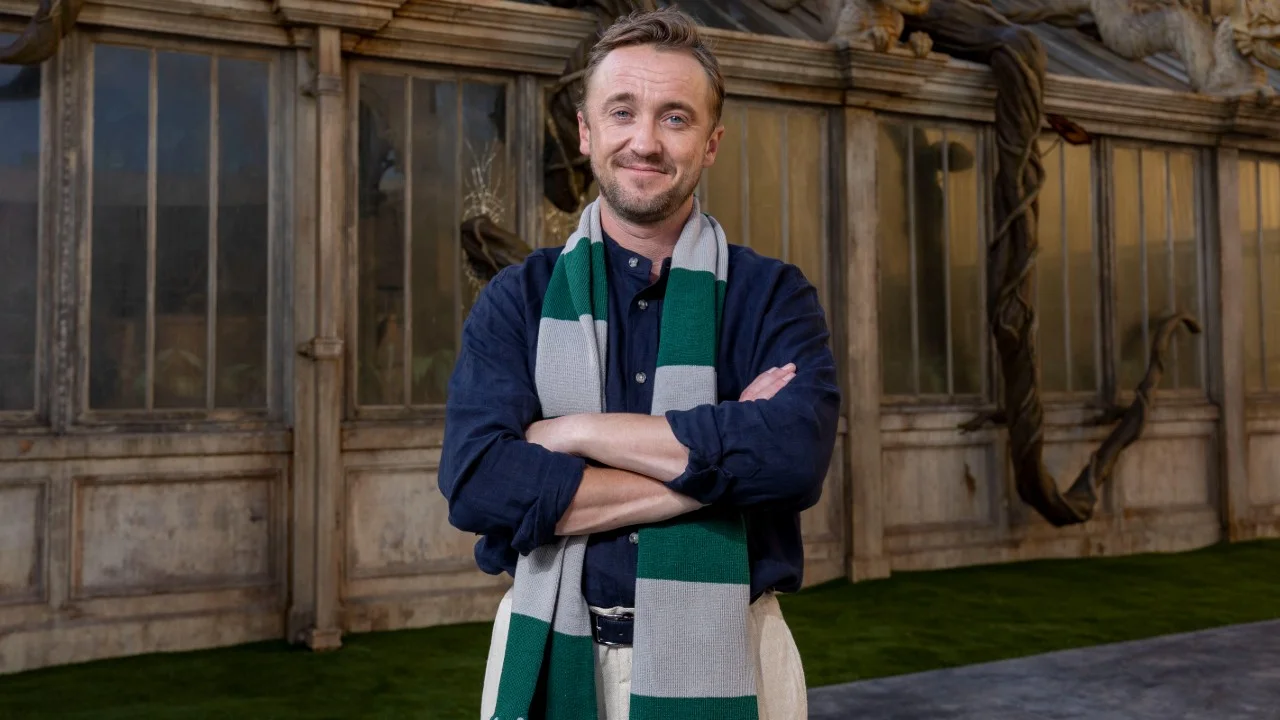Imagine an epic story inspired by this scene. In a world where the lines between magic and reality blur, Aelric discovered his calling as the Guardian of the Ancient Grove. The greenhouse behind him was no ordinary structure; it was the central sanctuary for the Order of the Veil, an ancient group sworn to protect the hidden realms of magic from the encroaching darkness. The twisted vines climbing the greenhouse's walls were not merely plants but sentient beings, guardians themselves, ever watchful of intruders. As Aelric stood poised, the weight of centuries of tradition rested on his shoulders, his calm demeanor masking the turbulent thoughts of war and peace. What magical abilities does Aelric possess as the Guardian? Aelric’s magical abilities are vast and profound. He commands the Elemental Magics, allowing him to manipulate earth, water, fire, and air with ease. The vines behind him respond to his will, capable of ensnaring enemies or blossoming into powerful herbs and flowers for healing and enchantment. Aelric also possesses the rare ability to commune with the Spirits of the Ancients, drawing wisdom and guidance from those who protected the grove before him. His most formidable power, however, is the Veilweaving – an intricate spellcasting art that lets him create, mend, or hide rifts between the human world and the mystical realms, ensuring the balance is maintained. 